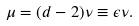Convert formula to latex. <formula><loc_0><loc_0><loc_500><loc_500>\mu = ( d - 2 ) \nu \equiv \epsilon \nu .</formula> 